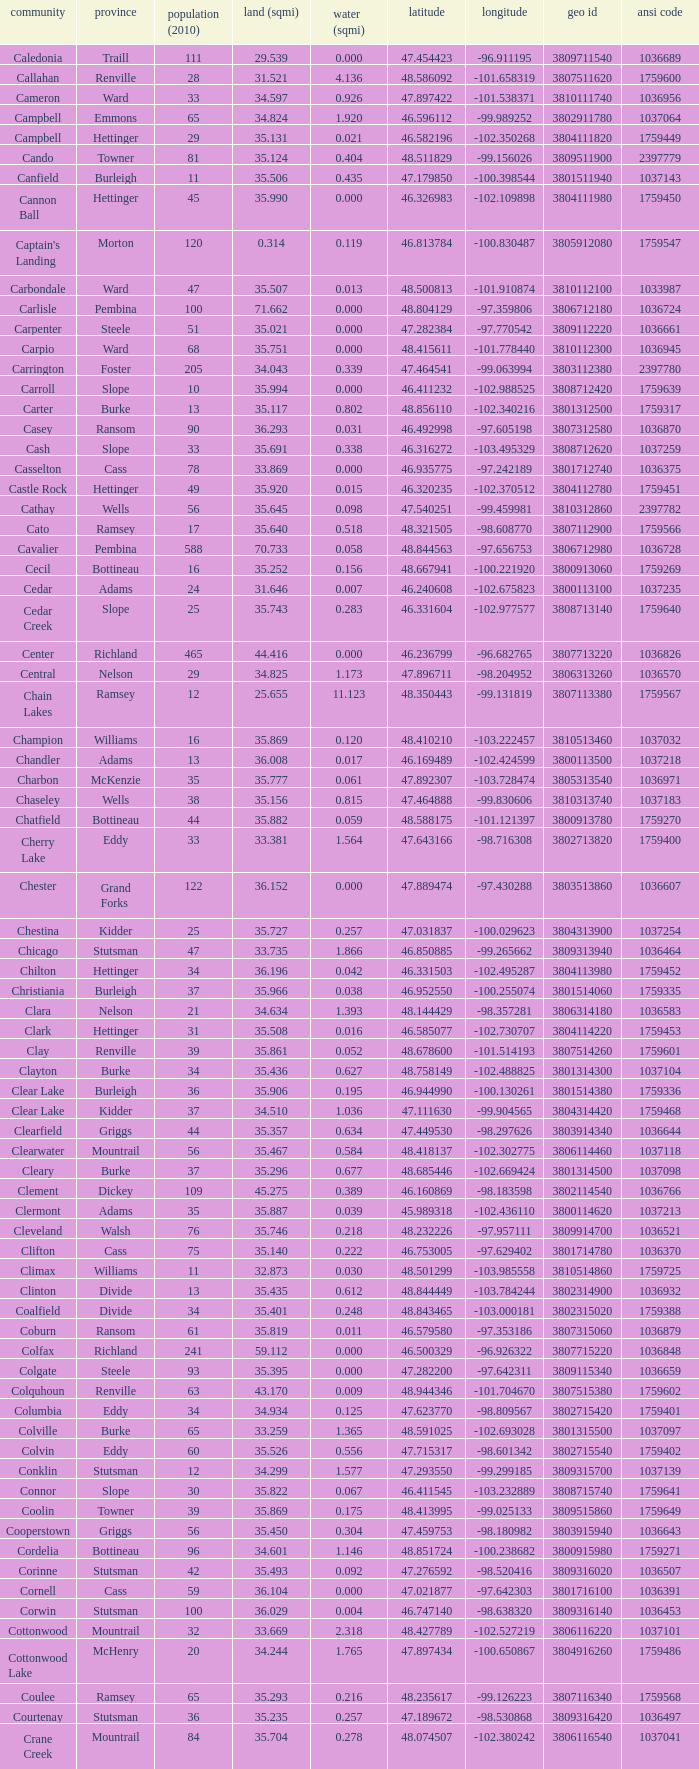Which county had a longitude of -102.302775? Mountrail. 